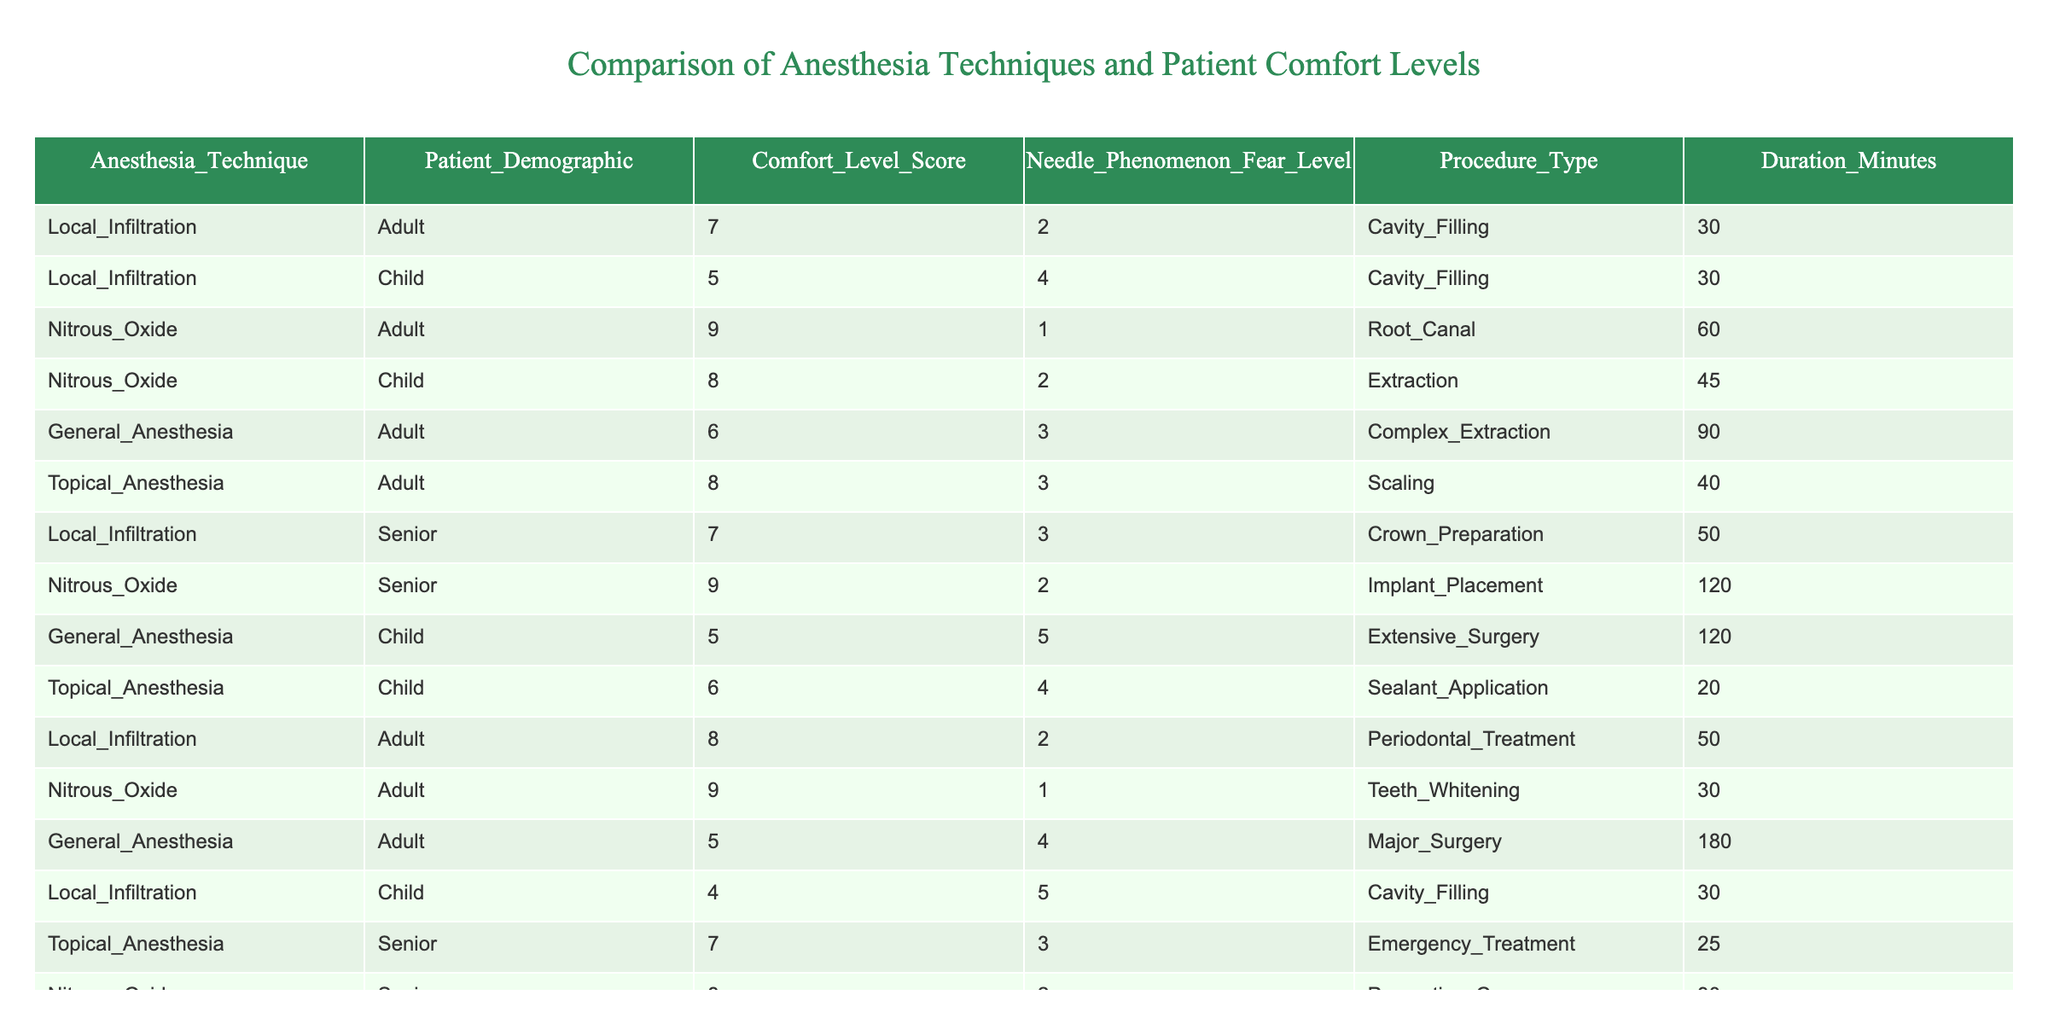What is the comfort level score for Nitrous Oxide in adults? In the table, I locate the row corresponding to Nitrous Oxide and Adult demographics. The associated comfort level score is listed as 9.
Answer: 9 What is the highest comfort level score recorded for any anesthesia technique? Scanning through the table, I find that the highest comfort level score is 9, which appears in the entries for Nitrous Oxide among both adults and seniors.
Answer: 9 Which anesthesia technique has the lowest comfort level score for children? I examine the rows for children and find their comfort level scores for Local Infiltration (4) and General Anesthesia (5). The lowest score is 4 for Local Infiltration.
Answer: Local Infiltration What is the average comfort level score for adults? I add the comfort scores for all adults: (7 + 9 + 6 + 8 + 9 + 5) = 44. There are 6 entries, so the average is 44 / 6 = approximately 7.33.
Answer: 7.33 What demographic shows the highest fear level associated with needle phenomena? Looking through the Needle Phenomenon Fear Levels, I see that for children receiving General Anesthesia, the fear level score is 5, which is the highest noted.
Answer: Child Does topical anesthesia provide a higher comfort level than general anesthesia for adults? Comparing the comfort levels in the table for Topical Anesthesia (8) and General Anesthesia (5) in adults, it is clear that Topical Anesthesia has a higher score.
Answer: Yes What is the total duration of procedures for patients receiving Nitrous Oxide? I sum the durations of procedures involving Nitrous Oxide: (60 + 45 + 120 + 30) = 255 minutes total across the relevant entries.
Answer: 255 Which procedure type has the highest comfort level score? I analyze the scores for each procedure type and find that the highest score of 9 is associated with Nitrous Oxide used for both Root Canal and Teeth Whitening.
Answer: Root Canal and Teeth Whitening Which demographic has the highest recorded comfort level when using Local Infiltration? I check the comfort scores for Local Infiltration for each demographic: Adults (7), Children (5), and Seniors (7). Both Adults and Seniors show the highest score of 7.
Answer: Adult and Senior Is there a patient demographic where general anesthesia has a better comfort level compared to local infiltration? Looking at the scores, Adults have a comfort level of 5 for General Anesthesia and 7 for Local Infiltration, indicating that General Anesthesia does not have a better score in this demographic.
Answer: No 